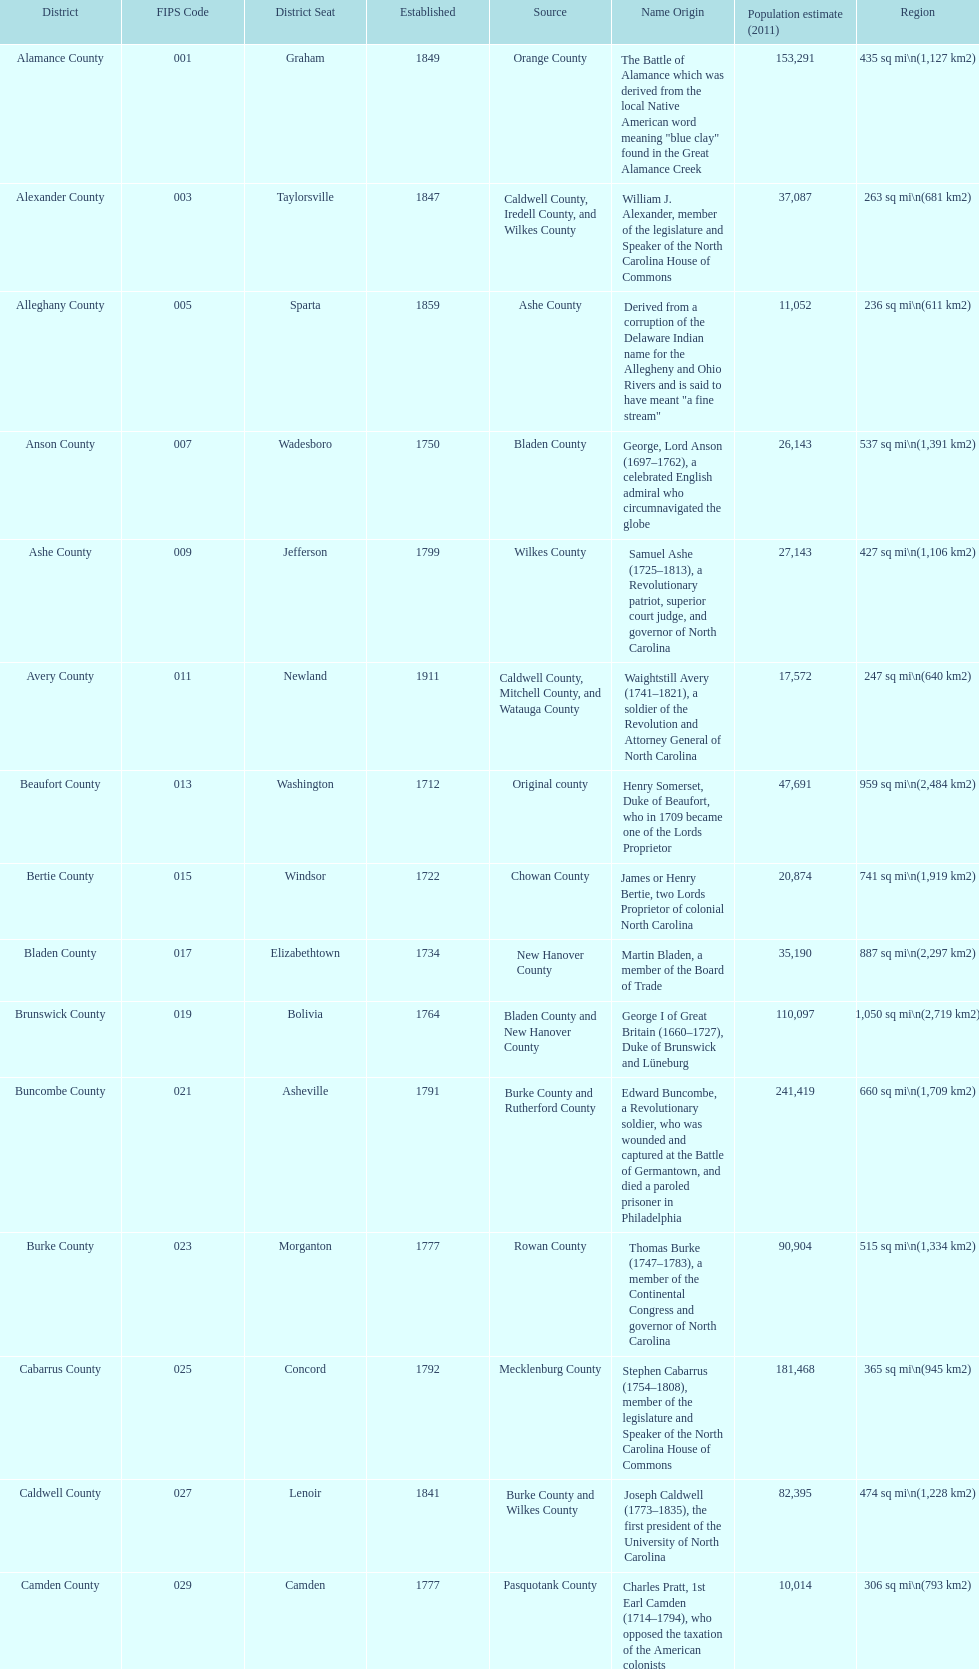What is the only county whose name comes from a battle? Alamance County. 